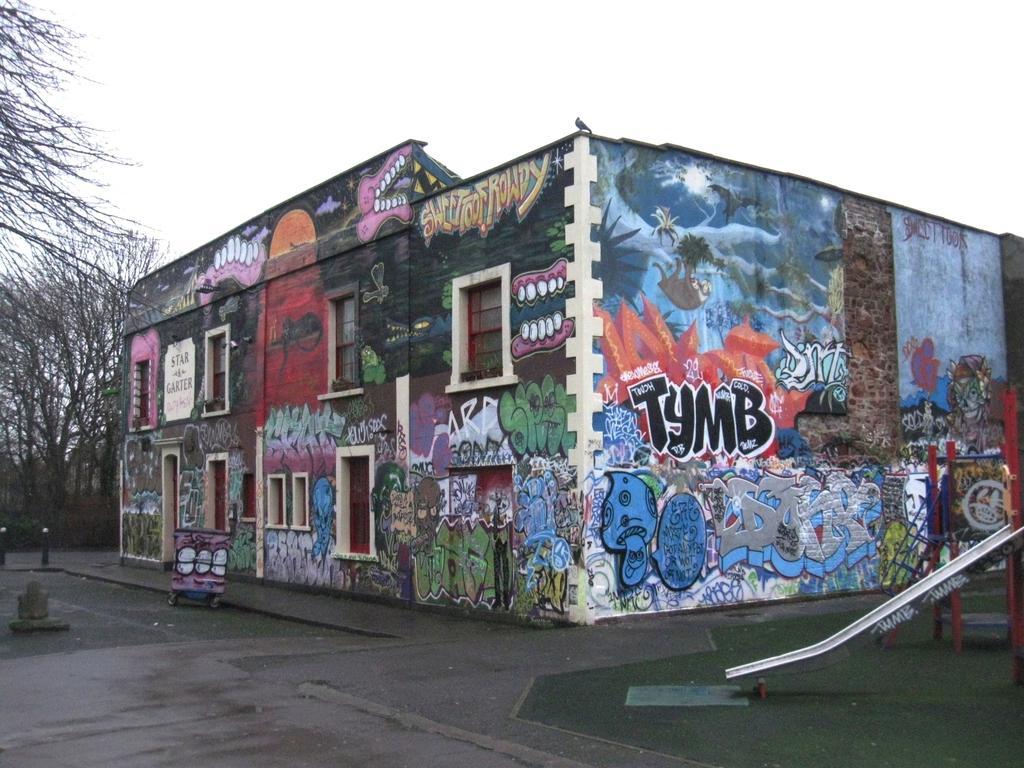Please provide a concise description of this image. In this image I can see a building, there are windows and there is painting on all the walls. In the bottom right corner there is a garden slide. Also there are trees and in the background there is sky. 